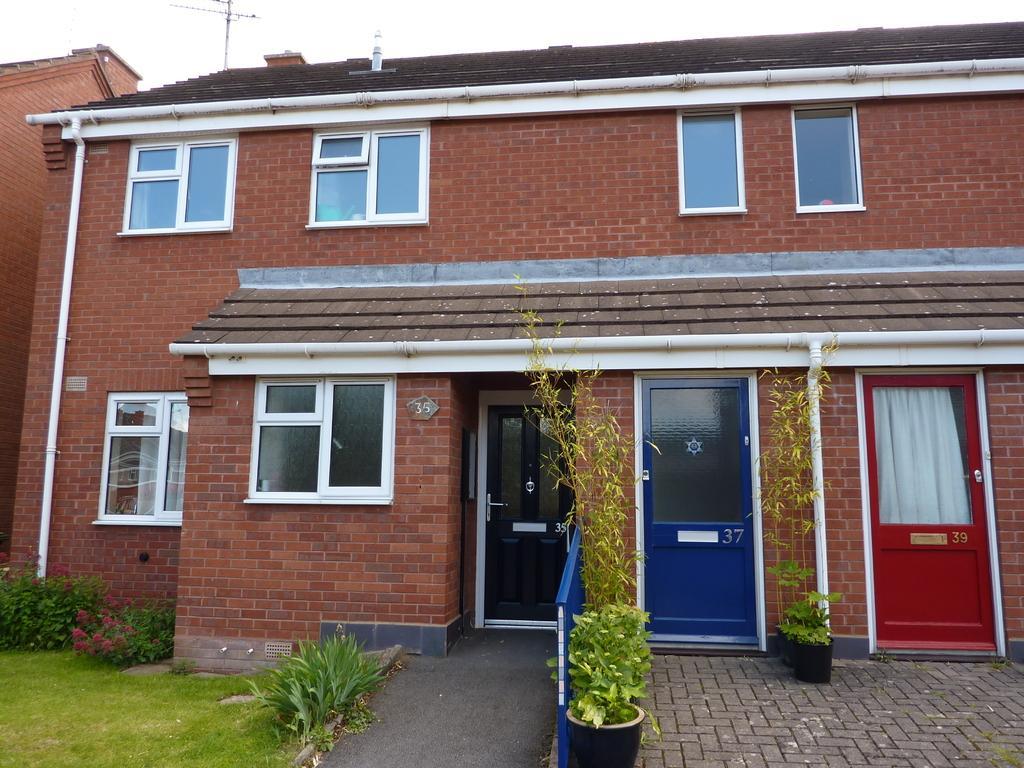Describe this image in one or two sentences. In this picture we can observe a building which is in brown color. We can observe three doors which are in black, blue and red colors. There are some plants and grass on the ground. In the background there is a sky. 